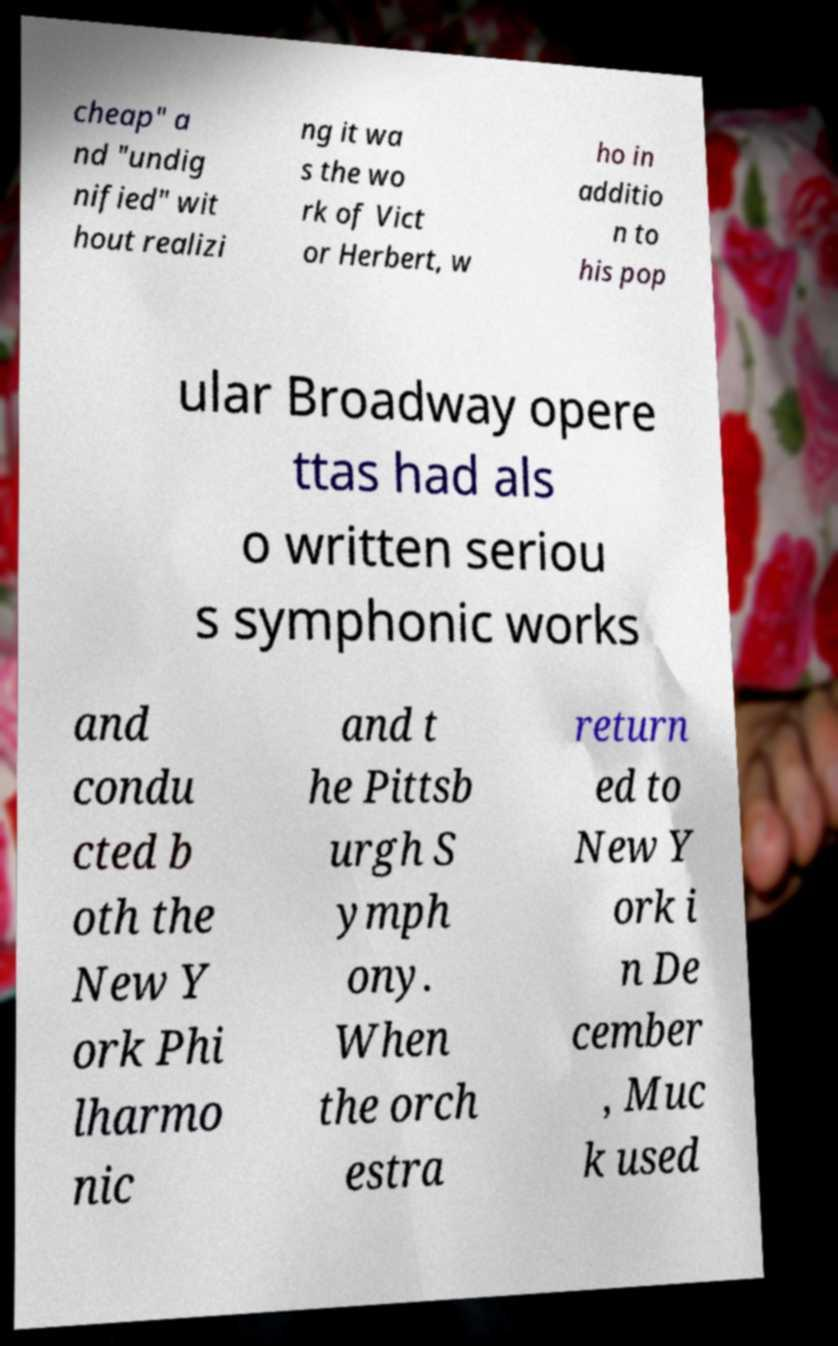Can you accurately transcribe the text from the provided image for me? cheap" a nd "undig nified" wit hout realizi ng it wa s the wo rk of Vict or Herbert, w ho in additio n to his pop ular Broadway opere ttas had als o written seriou s symphonic works and condu cted b oth the New Y ork Phi lharmo nic and t he Pittsb urgh S ymph ony. When the orch estra return ed to New Y ork i n De cember , Muc k used 